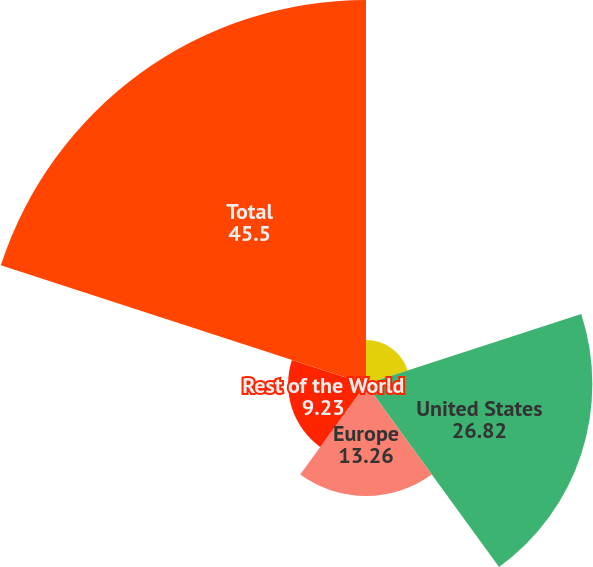Convert chart. <chart><loc_0><loc_0><loc_500><loc_500><pie_chart><fcel>Dollars in Millions<fcel>United States<fcel>Europe<fcel>Rest of the World<fcel>Total<nl><fcel>5.2%<fcel>26.82%<fcel>13.26%<fcel>9.23%<fcel>45.5%<nl></chart> 